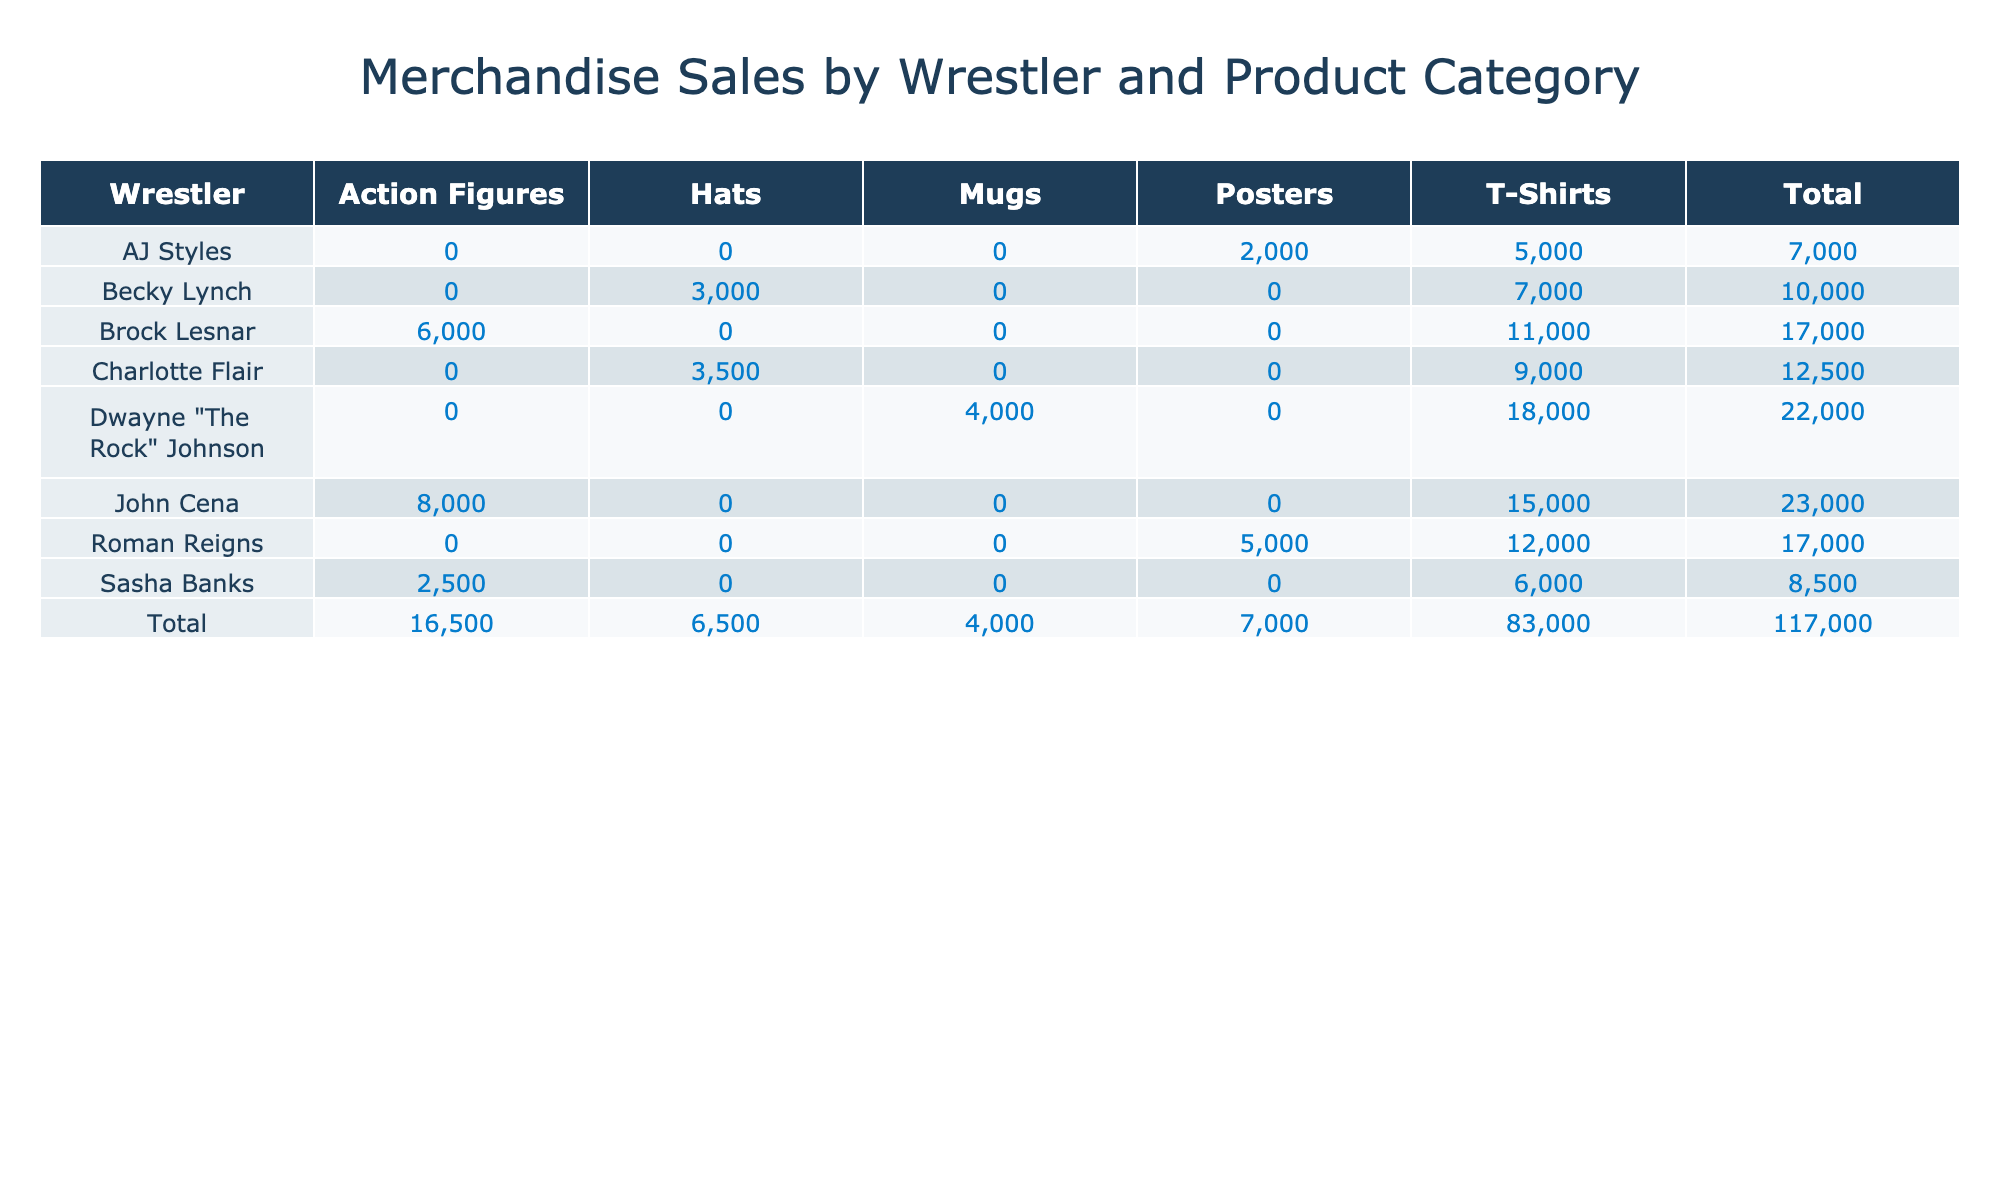What wrestler has the highest T-Shirt sales? By examining the T-Shirt sales column, the highest value is from Dwayne "The Rock" Johnson with 18000 sales.
Answer: Dwayne "The Rock" Johnson What is the total sales for Becky Lynch? To find the total sales for Becky Lynch, we add her sales in T-Shirts (7000) and Hats (3000): 7000 + 3000 = 10000.
Answer: 10000 Did Sasha Banks sell more Action Figures than Roman Reigns? Sasha Banks sold 2500 Action Figures, while Roman Reigns sold none (0) since the table does not list Action Figures for him. Therefore, the statement is false.
Answer: No What is the combined sales of T-Shirts for both John Cena and Brock Lesnar? John Cena's T-Shirt sales are 15000, and Brock Lesnar's are 11000. Adding these gives us 15000 + 11000 = 26000.
Answer: 26000 Which wrestler has the lowest total sales? To determine the lowest total sales, we need to calculate the total sales for each wrestler and compare them. AJ Styles has total sales of 7000 (T-Shirts) + 2000 (Posters) = 9000, the least among all.
Answer: AJ Styles What is the average T-Shirt sales among the wrestlers listed? The T-Shirt sales are: John Cena (15000), Roman Reigns (12000), Becky Lynch (7000), Sasha Banks (6000), Dwayne "The Rock" Johnson (18000), Brock Lesnar (11000), AJ Styles (5000), Charlotte Flair (9000). Their total is 15000 + 12000 + 7000 + 6000 + 18000 + 11000 + 5000 + 9000 = 83000. There are 8 wrestlers, so the average is 83000 / 8 = 10375.
Answer: 10375 Is there a wrestler who does not sell any Posters? Looking at the table, AJ Styles, Becky Lynch, Dwayne "The Rock" Johnson, and Brock Lesnar do not have sales listed under Posters. Therefore, it is true that multiple wrestlers do not sell Posters.
Answer: Yes What is the difference in total sales between Dwayne "The Rock" Johnson and Roman Reigns? Dwayne "The Rock" Johnson's total sales are 18000 (T-Shirts) + 4000 (Mugs) = 22000, and Roman Reigns has a total of 12000 (T-Shirts) + 5000 (Posters) = 17000. The difference is 22000 - 17000 = 5000.
Answer: 5000 What product category did John Cena sell the least of? John Cena sold 15000 in T-Shirts and 8000 in Action Figures. The least is Action Figures with 8000 sales.
Answer: Action Figures 